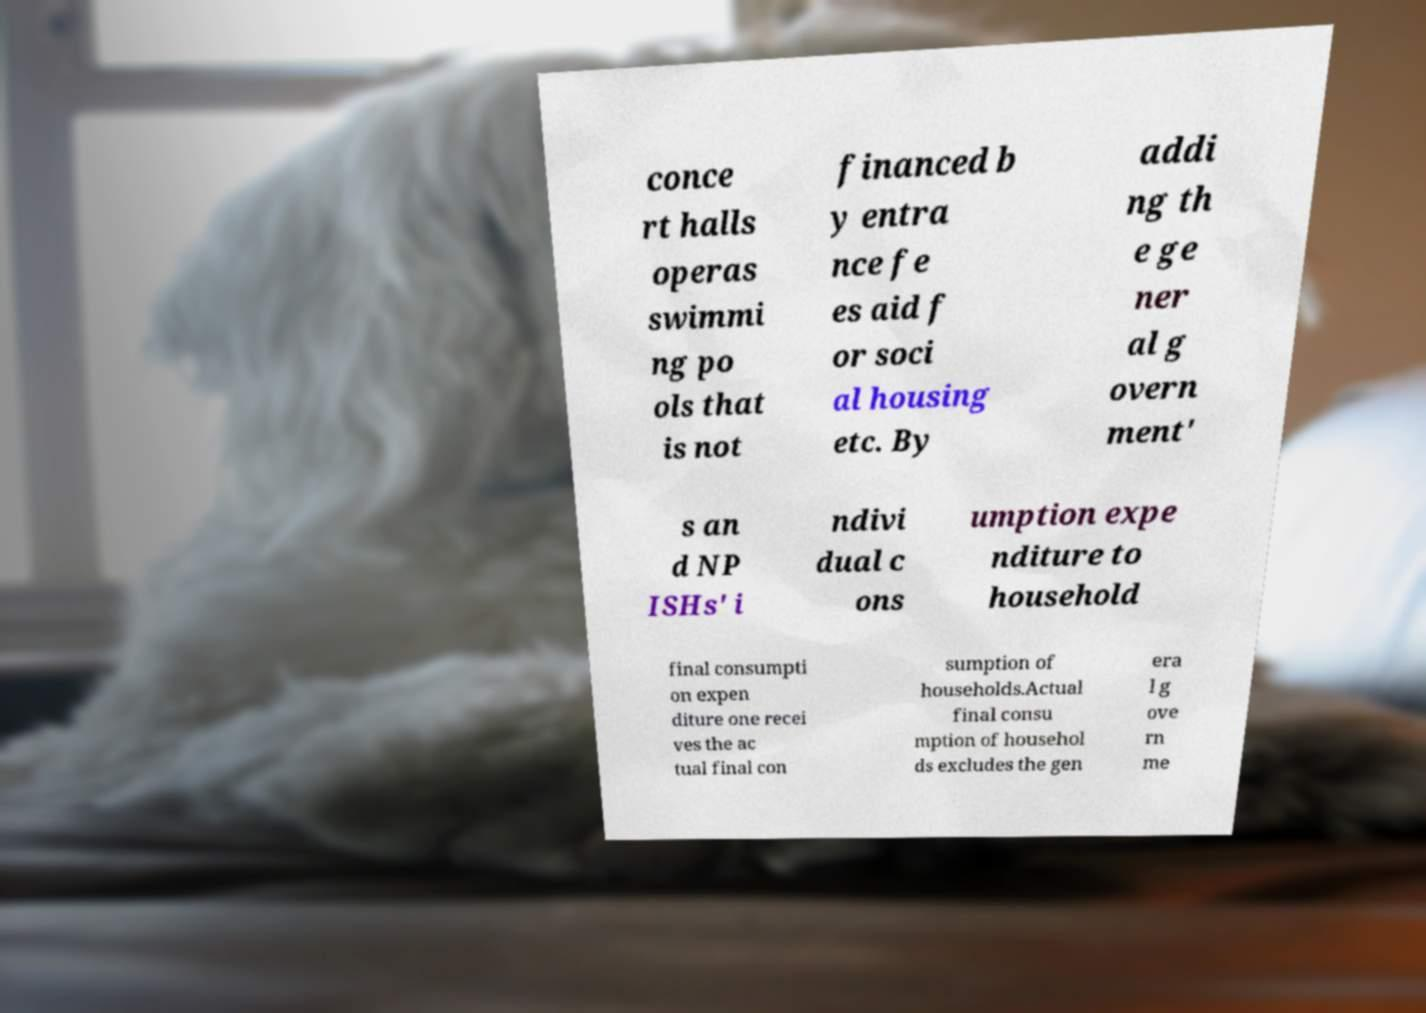I need the written content from this picture converted into text. Can you do that? conce rt halls operas swimmi ng po ols that is not financed b y entra nce fe es aid f or soci al housing etc. By addi ng th e ge ner al g overn ment' s an d NP ISHs' i ndivi dual c ons umption expe nditure to household final consumpti on expen diture one recei ves the ac tual final con sumption of households.Actual final consu mption of househol ds excludes the gen era l g ove rn me 